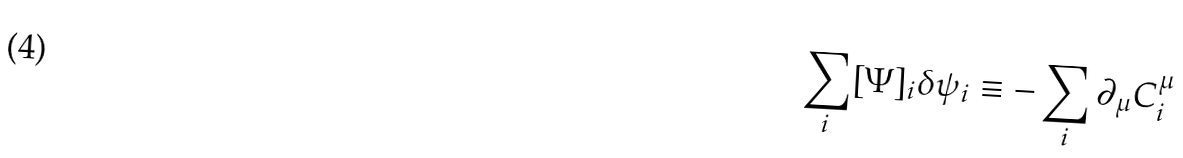<formula> <loc_0><loc_0><loc_500><loc_500>\sum _ { i } [ \Psi ] _ { i } \delta \psi _ { i } \equiv - \sum _ { i } \partial _ { \mu } C _ { i } ^ { \mu }</formula> 